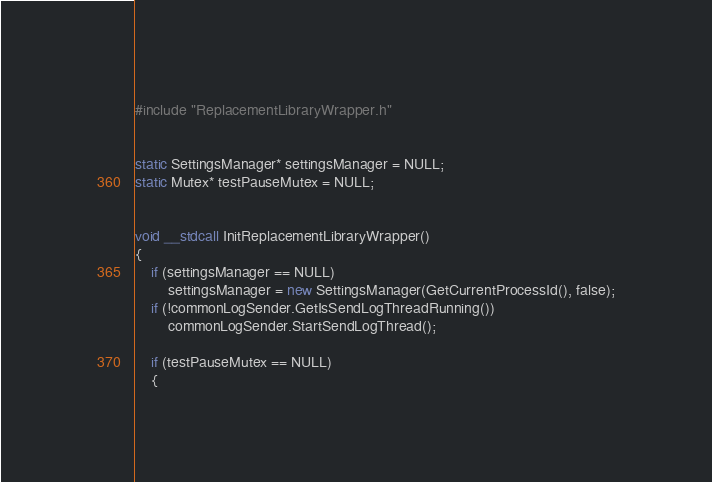<code> <loc_0><loc_0><loc_500><loc_500><_C++_>#include "ReplacementLibraryWrapper.h"


static SettingsManager* settingsManager = NULL;
static Mutex* testPauseMutex = NULL;


void __stdcall InitReplacementLibraryWrapper()
{
	if (settingsManager == NULL)
		settingsManager = new SettingsManager(GetCurrentProcessId(), false);
	if (!commonLogSender.GetIsSendLogThreadRunning())
		commonLogSender.StartSendLogThread();

	if (testPauseMutex == NULL)
	{</code> 